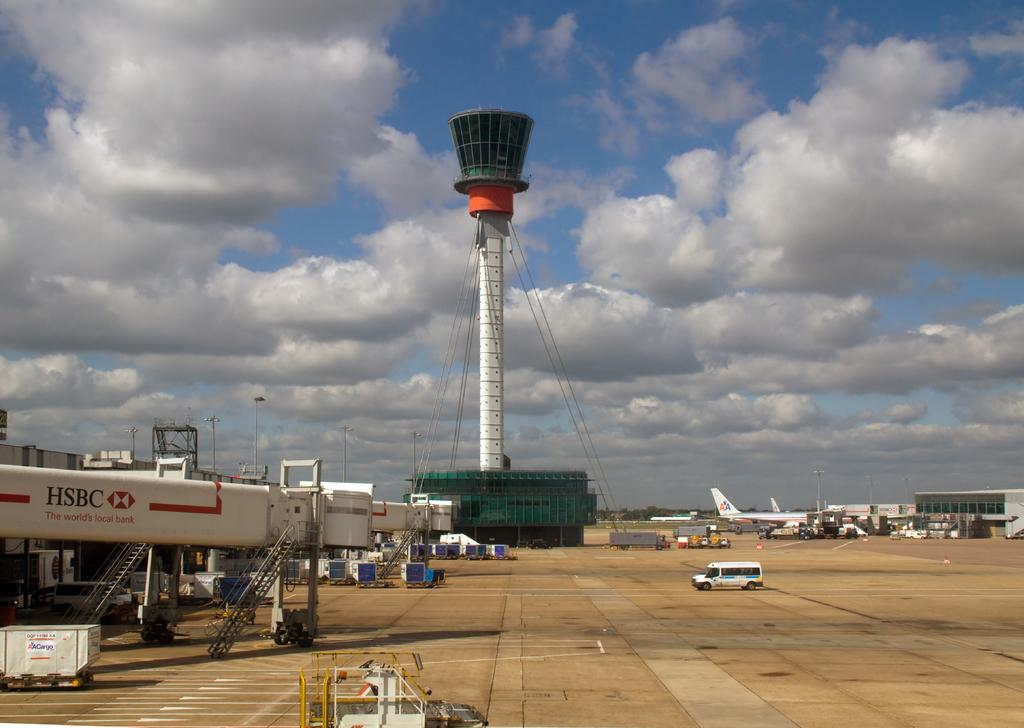<image>
Write a terse but informative summary of the picture. At an airport, some American Airlines jets are visible in the distance. 